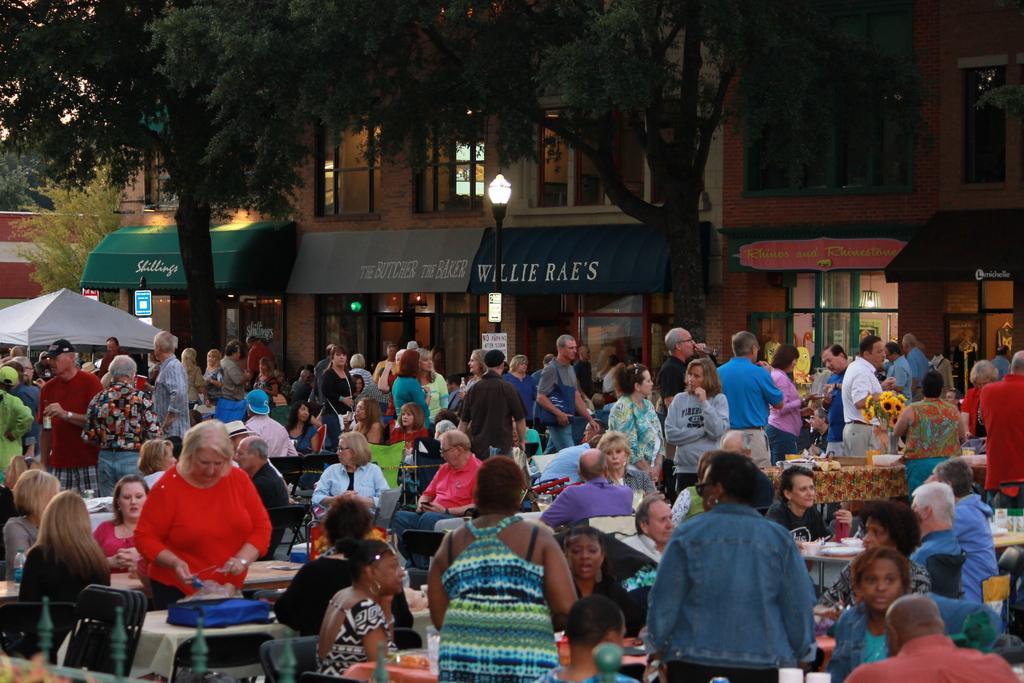How would you summarize this image in a sentence or two? In this picture there are group people, some are sitting and standing and there is a building and trees in the backdrop. 